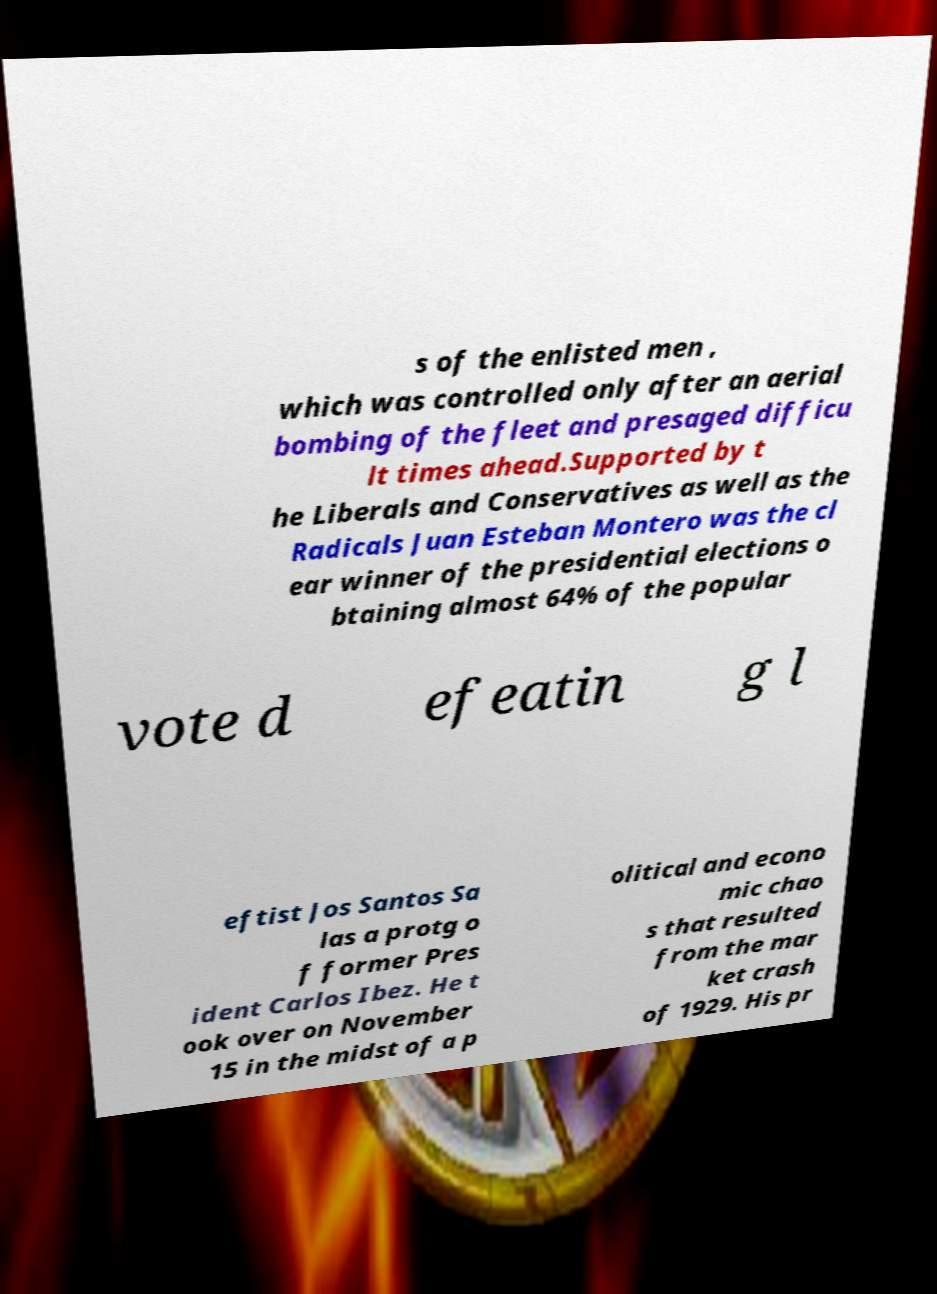Can you read and provide the text displayed in the image?This photo seems to have some interesting text. Can you extract and type it out for me? s of the enlisted men , which was controlled only after an aerial bombing of the fleet and presaged difficu lt times ahead.Supported by t he Liberals and Conservatives as well as the Radicals Juan Esteban Montero was the cl ear winner of the presidential elections o btaining almost 64% of the popular vote d efeatin g l eftist Jos Santos Sa las a protg o f former Pres ident Carlos Ibez. He t ook over on November 15 in the midst of a p olitical and econo mic chao s that resulted from the mar ket crash of 1929. His pr 